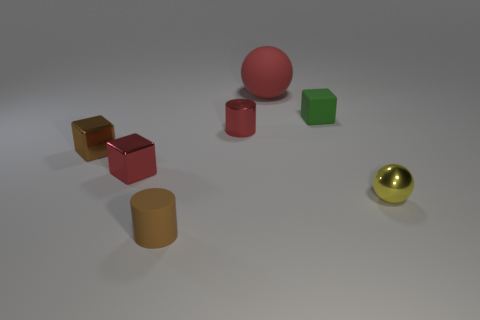There is a ball in front of the large red rubber thing; does it have the same size as the red block that is in front of the tiny green matte block?
Keep it short and to the point. Yes. There is a red metallic cylinder in front of the tiny green matte block; what is its size?
Ensure brevity in your answer.  Small. Is there a small rubber cylinder of the same color as the small sphere?
Provide a short and direct response. No. Is there a small rubber object to the right of the rubber thing that is to the left of the matte sphere?
Offer a terse response. Yes. Is the size of the metallic sphere the same as the red object to the right of the shiny cylinder?
Make the answer very short. No. There is a tiny matte thing that is to the left of the ball that is behind the tiny yellow object; is there a red shiny object that is right of it?
Ensure brevity in your answer.  Yes. There is a small cylinder that is behind the tiny yellow metallic object; what material is it?
Provide a short and direct response. Metal. Do the rubber cylinder and the red rubber ball have the same size?
Provide a short and direct response. No. The matte object that is both left of the tiny green object and behind the matte cylinder is what color?
Ensure brevity in your answer.  Red. The tiny brown object that is the same material as the big red ball is what shape?
Provide a short and direct response. Cylinder. 